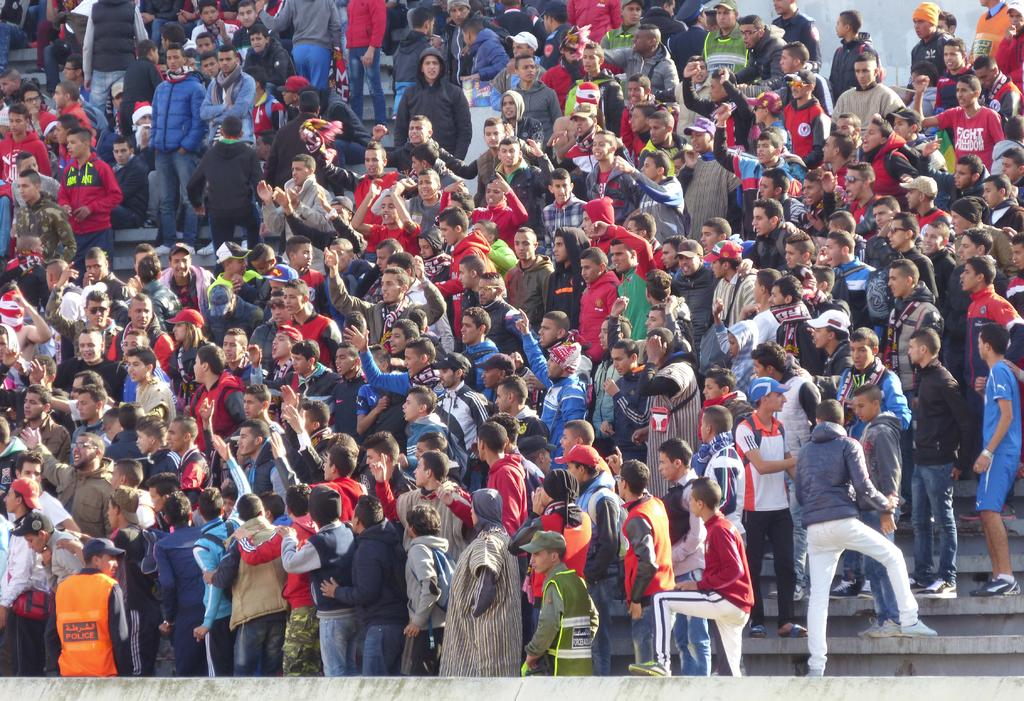How many people are in the image? There are multiple persons in the image. What are the people in the image doing? Some of the persons are standing, while others are sitting. What can be seen in the background of the image? There is a wall in the background of the image. What type of crow can be seen playing an instrument in the image? There is no crow or instrument present in the image. How many zebras are visible in the image? There are no zebras present in the image. 